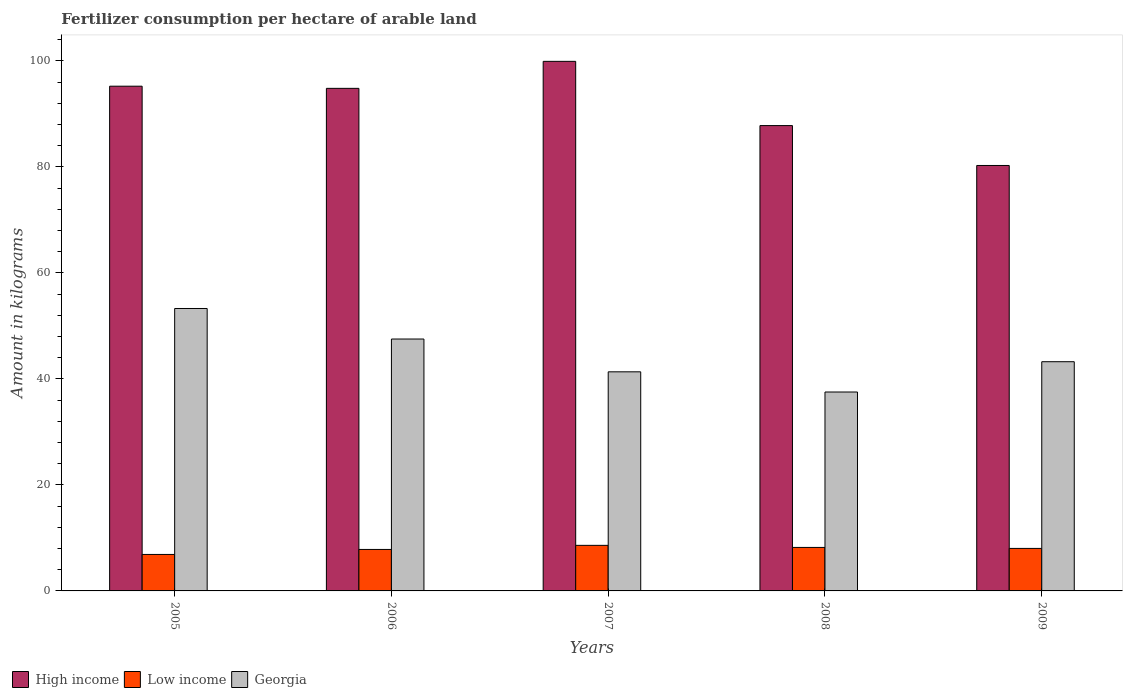How many groups of bars are there?
Your answer should be compact. 5. Are the number of bars per tick equal to the number of legend labels?
Offer a terse response. Yes. Are the number of bars on each tick of the X-axis equal?
Keep it short and to the point. Yes. How many bars are there on the 2nd tick from the left?
Your answer should be very brief. 3. How many bars are there on the 4th tick from the right?
Your response must be concise. 3. In how many cases, is the number of bars for a given year not equal to the number of legend labels?
Your answer should be compact. 0. What is the amount of fertilizer consumption in High income in 2006?
Ensure brevity in your answer.  94.83. Across all years, what is the maximum amount of fertilizer consumption in Low income?
Offer a terse response. 8.6. Across all years, what is the minimum amount of fertilizer consumption in Low income?
Provide a short and direct response. 6.88. What is the total amount of fertilizer consumption in Low income in the graph?
Your response must be concise. 39.53. What is the difference between the amount of fertilizer consumption in High income in 2007 and that in 2008?
Offer a very short reply. 12.12. What is the difference between the amount of fertilizer consumption in High income in 2007 and the amount of fertilizer consumption in Georgia in 2005?
Ensure brevity in your answer.  46.63. What is the average amount of fertilizer consumption in Low income per year?
Make the answer very short. 7.91. In the year 2008, what is the difference between the amount of fertilizer consumption in High income and amount of fertilizer consumption in Low income?
Ensure brevity in your answer.  79.59. What is the ratio of the amount of fertilizer consumption in High income in 2006 to that in 2009?
Ensure brevity in your answer.  1.18. Is the amount of fertilizer consumption in Low income in 2008 less than that in 2009?
Provide a succinct answer. No. Is the difference between the amount of fertilizer consumption in High income in 2008 and 2009 greater than the difference between the amount of fertilizer consumption in Low income in 2008 and 2009?
Keep it short and to the point. Yes. What is the difference between the highest and the second highest amount of fertilizer consumption in High income?
Offer a terse response. 4.69. What is the difference between the highest and the lowest amount of fertilizer consumption in Low income?
Provide a succinct answer. 1.72. In how many years, is the amount of fertilizer consumption in Low income greater than the average amount of fertilizer consumption in Low income taken over all years?
Ensure brevity in your answer.  3. What does the 1st bar from the right in 2008 represents?
Provide a short and direct response. Georgia. Are all the bars in the graph horizontal?
Your response must be concise. No. What is the difference between two consecutive major ticks on the Y-axis?
Provide a short and direct response. 20. Are the values on the major ticks of Y-axis written in scientific E-notation?
Offer a terse response. No. How are the legend labels stacked?
Ensure brevity in your answer.  Horizontal. What is the title of the graph?
Keep it short and to the point. Fertilizer consumption per hectare of arable land. What is the label or title of the Y-axis?
Offer a terse response. Amount in kilograms. What is the Amount in kilograms in High income in 2005?
Your response must be concise. 95.23. What is the Amount in kilograms of Low income in 2005?
Give a very brief answer. 6.88. What is the Amount in kilograms of Georgia in 2005?
Ensure brevity in your answer.  53.29. What is the Amount in kilograms in High income in 2006?
Make the answer very short. 94.83. What is the Amount in kilograms in Low income in 2006?
Your response must be concise. 7.83. What is the Amount in kilograms in Georgia in 2006?
Your response must be concise. 47.53. What is the Amount in kilograms of High income in 2007?
Give a very brief answer. 99.92. What is the Amount in kilograms of Low income in 2007?
Give a very brief answer. 8.6. What is the Amount in kilograms of Georgia in 2007?
Keep it short and to the point. 41.34. What is the Amount in kilograms of High income in 2008?
Your answer should be compact. 87.8. What is the Amount in kilograms in Low income in 2008?
Your answer should be compact. 8.21. What is the Amount in kilograms of Georgia in 2008?
Provide a short and direct response. 37.53. What is the Amount in kilograms of High income in 2009?
Provide a short and direct response. 80.27. What is the Amount in kilograms in Low income in 2009?
Make the answer very short. 8.02. What is the Amount in kilograms in Georgia in 2009?
Make the answer very short. 43.25. Across all years, what is the maximum Amount in kilograms in High income?
Your answer should be compact. 99.92. Across all years, what is the maximum Amount in kilograms in Low income?
Keep it short and to the point. 8.6. Across all years, what is the maximum Amount in kilograms in Georgia?
Your response must be concise. 53.29. Across all years, what is the minimum Amount in kilograms in High income?
Give a very brief answer. 80.27. Across all years, what is the minimum Amount in kilograms in Low income?
Provide a short and direct response. 6.88. Across all years, what is the minimum Amount in kilograms of Georgia?
Your answer should be compact. 37.53. What is the total Amount in kilograms of High income in the graph?
Ensure brevity in your answer.  458.05. What is the total Amount in kilograms of Low income in the graph?
Provide a short and direct response. 39.53. What is the total Amount in kilograms in Georgia in the graph?
Offer a very short reply. 222.93. What is the difference between the Amount in kilograms of High income in 2005 and that in 2006?
Give a very brief answer. 0.41. What is the difference between the Amount in kilograms of Low income in 2005 and that in 2006?
Provide a short and direct response. -0.95. What is the difference between the Amount in kilograms of Georgia in 2005 and that in 2006?
Your answer should be very brief. 5.76. What is the difference between the Amount in kilograms of High income in 2005 and that in 2007?
Give a very brief answer. -4.69. What is the difference between the Amount in kilograms in Low income in 2005 and that in 2007?
Your answer should be very brief. -1.72. What is the difference between the Amount in kilograms of Georgia in 2005 and that in 2007?
Your answer should be compact. 11.95. What is the difference between the Amount in kilograms in High income in 2005 and that in 2008?
Keep it short and to the point. 7.43. What is the difference between the Amount in kilograms in Low income in 2005 and that in 2008?
Your answer should be very brief. -1.33. What is the difference between the Amount in kilograms of Georgia in 2005 and that in 2008?
Offer a very short reply. 15.76. What is the difference between the Amount in kilograms of High income in 2005 and that in 2009?
Your response must be concise. 14.96. What is the difference between the Amount in kilograms in Low income in 2005 and that in 2009?
Offer a very short reply. -1.14. What is the difference between the Amount in kilograms in Georgia in 2005 and that in 2009?
Ensure brevity in your answer.  10.04. What is the difference between the Amount in kilograms of High income in 2006 and that in 2007?
Offer a terse response. -5.09. What is the difference between the Amount in kilograms in Low income in 2006 and that in 2007?
Your answer should be compact. -0.77. What is the difference between the Amount in kilograms of Georgia in 2006 and that in 2007?
Your answer should be compact. 6.19. What is the difference between the Amount in kilograms in High income in 2006 and that in 2008?
Provide a succinct answer. 7.03. What is the difference between the Amount in kilograms of Low income in 2006 and that in 2008?
Your response must be concise. -0.38. What is the difference between the Amount in kilograms of Georgia in 2006 and that in 2008?
Offer a terse response. 10. What is the difference between the Amount in kilograms of High income in 2006 and that in 2009?
Offer a terse response. 14.55. What is the difference between the Amount in kilograms in Low income in 2006 and that in 2009?
Your answer should be very brief. -0.19. What is the difference between the Amount in kilograms of Georgia in 2006 and that in 2009?
Your answer should be very brief. 4.28. What is the difference between the Amount in kilograms of High income in 2007 and that in 2008?
Make the answer very short. 12.12. What is the difference between the Amount in kilograms in Low income in 2007 and that in 2008?
Your response must be concise. 0.39. What is the difference between the Amount in kilograms in Georgia in 2007 and that in 2008?
Offer a terse response. 3.81. What is the difference between the Amount in kilograms of High income in 2007 and that in 2009?
Ensure brevity in your answer.  19.65. What is the difference between the Amount in kilograms in Low income in 2007 and that in 2009?
Your answer should be very brief. 0.58. What is the difference between the Amount in kilograms in Georgia in 2007 and that in 2009?
Your answer should be compact. -1.91. What is the difference between the Amount in kilograms in High income in 2008 and that in 2009?
Your response must be concise. 7.53. What is the difference between the Amount in kilograms of Low income in 2008 and that in 2009?
Your answer should be compact. 0.19. What is the difference between the Amount in kilograms in Georgia in 2008 and that in 2009?
Ensure brevity in your answer.  -5.72. What is the difference between the Amount in kilograms in High income in 2005 and the Amount in kilograms in Low income in 2006?
Your answer should be very brief. 87.4. What is the difference between the Amount in kilograms of High income in 2005 and the Amount in kilograms of Georgia in 2006?
Offer a terse response. 47.7. What is the difference between the Amount in kilograms of Low income in 2005 and the Amount in kilograms of Georgia in 2006?
Provide a short and direct response. -40.65. What is the difference between the Amount in kilograms of High income in 2005 and the Amount in kilograms of Low income in 2007?
Provide a succinct answer. 86.63. What is the difference between the Amount in kilograms of High income in 2005 and the Amount in kilograms of Georgia in 2007?
Offer a terse response. 53.89. What is the difference between the Amount in kilograms in Low income in 2005 and the Amount in kilograms in Georgia in 2007?
Offer a terse response. -34.46. What is the difference between the Amount in kilograms in High income in 2005 and the Amount in kilograms in Low income in 2008?
Your answer should be compact. 87.02. What is the difference between the Amount in kilograms of High income in 2005 and the Amount in kilograms of Georgia in 2008?
Ensure brevity in your answer.  57.7. What is the difference between the Amount in kilograms of Low income in 2005 and the Amount in kilograms of Georgia in 2008?
Offer a very short reply. -30.65. What is the difference between the Amount in kilograms in High income in 2005 and the Amount in kilograms in Low income in 2009?
Your answer should be very brief. 87.21. What is the difference between the Amount in kilograms of High income in 2005 and the Amount in kilograms of Georgia in 2009?
Ensure brevity in your answer.  51.98. What is the difference between the Amount in kilograms of Low income in 2005 and the Amount in kilograms of Georgia in 2009?
Ensure brevity in your answer.  -36.37. What is the difference between the Amount in kilograms in High income in 2006 and the Amount in kilograms in Low income in 2007?
Give a very brief answer. 86.23. What is the difference between the Amount in kilograms of High income in 2006 and the Amount in kilograms of Georgia in 2007?
Give a very brief answer. 53.49. What is the difference between the Amount in kilograms of Low income in 2006 and the Amount in kilograms of Georgia in 2007?
Keep it short and to the point. -33.51. What is the difference between the Amount in kilograms of High income in 2006 and the Amount in kilograms of Low income in 2008?
Give a very brief answer. 86.62. What is the difference between the Amount in kilograms of High income in 2006 and the Amount in kilograms of Georgia in 2008?
Provide a succinct answer. 57.29. What is the difference between the Amount in kilograms in Low income in 2006 and the Amount in kilograms in Georgia in 2008?
Give a very brief answer. -29.7. What is the difference between the Amount in kilograms in High income in 2006 and the Amount in kilograms in Low income in 2009?
Offer a very short reply. 86.81. What is the difference between the Amount in kilograms in High income in 2006 and the Amount in kilograms in Georgia in 2009?
Provide a succinct answer. 51.58. What is the difference between the Amount in kilograms in Low income in 2006 and the Amount in kilograms in Georgia in 2009?
Keep it short and to the point. -35.42. What is the difference between the Amount in kilograms in High income in 2007 and the Amount in kilograms in Low income in 2008?
Provide a succinct answer. 91.71. What is the difference between the Amount in kilograms in High income in 2007 and the Amount in kilograms in Georgia in 2008?
Provide a short and direct response. 62.39. What is the difference between the Amount in kilograms in Low income in 2007 and the Amount in kilograms in Georgia in 2008?
Provide a succinct answer. -28.93. What is the difference between the Amount in kilograms of High income in 2007 and the Amount in kilograms of Low income in 2009?
Offer a very short reply. 91.9. What is the difference between the Amount in kilograms of High income in 2007 and the Amount in kilograms of Georgia in 2009?
Your response must be concise. 56.67. What is the difference between the Amount in kilograms in Low income in 2007 and the Amount in kilograms in Georgia in 2009?
Ensure brevity in your answer.  -34.65. What is the difference between the Amount in kilograms of High income in 2008 and the Amount in kilograms of Low income in 2009?
Your answer should be very brief. 79.78. What is the difference between the Amount in kilograms in High income in 2008 and the Amount in kilograms in Georgia in 2009?
Provide a short and direct response. 44.55. What is the difference between the Amount in kilograms in Low income in 2008 and the Amount in kilograms in Georgia in 2009?
Ensure brevity in your answer.  -35.04. What is the average Amount in kilograms in High income per year?
Offer a terse response. 91.61. What is the average Amount in kilograms of Low income per year?
Offer a terse response. 7.91. What is the average Amount in kilograms in Georgia per year?
Your response must be concise. 44.59. In the year 2005, what is the difference between the Amount in kilograms in High income and Amount in kilograms in Low income?
Make the answer very short. 88.35. In the year 2005, what is the difference between the Amount in kilograms of High income and Amount in kilograms of Georgia?
Your answer should be very brief. 41.94. In the year 2005, what is the difference between the Amount in kilograms of Low income and Amount in kilograms of Georgia?
Your response must be concise. -46.41. In the year 2006, what is the difference between the Amount in kilograms of High income and Amount in kilograms of Low income?
Offer a terse response. 87. In the year 2006, what is the difference between the Amount in kilograms of High income and Amount in kilograms of Georgia?
Provide a short and direct response. 47.3. In the year 2006, what is the difference between the Amount in kilograms in Low income and Amount in kilograms in Georgia?
Provide a short and direct response. -39.7. In the year 2007, what is the difference between the Amount in kilograms of High income and Amount in kilograms of Low income?
Provide a succinct answer. 91.32. In the year 2007, what is the difference between the Amount in kilograms of High income and Amount in kilograms of Georgia?
Keep it short and to the point. 58.58. In the year 2007, what is the difference between the Amount in kilograms in Low income and Amount in kilograms in Georgia?
Keep it short and to the point. -32.74. In the year 2008, what is the difference between the Amount in kilograms in High income and Amount in kilograms in Low income?
Make the answer very short. 79.59. In the year 2008, what is the difference between the Amount in kilograms of High income and Amount in kilograms of Georgia?
Offer a very short reply. 50.27. In the year 2008, what is the difference between the Amount in kilograms in Low income and Amount in kilograms in Georgia?
Make the answer very short. -29.32. In the year 2009, what is the difference between the Amount in kilograms of High income and Amount in kilograms of Low income?
Your response must be concise. 72.25. In the year 2009, what is the difference between the Amount in kilograms of High income and Amount in kilograms of Georgia?
Your response must be concise. 37.03. In the year 2009, what is the difference between the Amount in kilograms in Low income and Amount in kilograms in Georgia?
Keep it short and to the point. -35.23. What is the ratio of the Amount in kilograms of High income in 2005 to that in 2006?
Your answer should be very brief. 1. What is the ratio of the Amount in kilograms of Low income in 2005 to that in 2006?
Your answer should be very brief. 0.88. What is the ratio of the Amount in kilograms of Georgia in 2005 to that in 2006?
Your response must be concise. 1.12. What is the ratio of the Amount in kilograms of High income in 2005 to that in 2007?
Offer a very short reply. 0.95. What is the ratio of the Amount in kilograms in Low income in 2005 to that in 2007?
Your answer should be compact. 0.8. What is the ratio of the Amount in kilograms in Georgia in 2005 to that in 2007?
Provide a succinct answer. 1.29. What is the ratio of the Amount in kilograms in High income in 2005 to that in 2008?
Offer a terse response. 1.08. What is the ratio of the Amount in kilograms of Low income in 2005 to that in 2008?
Provide a short and direct response. 0.84. What is the ratio of the Amount in kilograms of Georgia in 2005 to that in 2008?
Make the answer very short. 1.42. What is the ratio of the Amount in kilograms of High income in 2005 to that in 2009?
Provide a succinct answer. 1.19. What is the ratio of the Amount in kilograms in Low income in 2005 to that in 2009?
Your answer should be compact. 0.86. What is the ratio of the Amount in kilograms in Georgia in 2005 to that in 2009?
Keep it short and to the point. 1.23. What is the ratio of the Amount in kilograms in High income in 2006 to that in 2007?
Make the answer very short. 0.95. What is the ratio of the Amount in kilograms in Low income in 2006 to that in 2007?
Keep it short and to the point. 0.91. What is the ratio of the Amount in kilograms of Georgia in 2006 to that in 2007?
Offer a terse response. 1.15. What is the ratio of the Amount in kilograms of High income in 2006 to that in 2008?
Provide a short and direct response. 1.08. What is the ratio of the Amount in kilograms of Low income in 2006 to that in 2008?
Make the answer very short. 0.95. What is the ratio of the Amount in kilograms in Georgia in 2006 to that in 2008?
Offer a terse response. 1.27. What is the ratio of the Amount in kilograms of High income in 2006 to that in 2009?
Provide a short and direct response. 1.18. What is the ratio of the Amount in kilograms of Low income in 2006 to that in 2009?
Offer a very short reply. 0.98. What is the ratio of the Amount in kilograms of Georgia in 2006 to that in 2009?
Offer a very short reply. 1.1. What is the ratio of the Amount in kilograms of High income in 2007 to that in 2008?
Provide a succinct answer. 1.14. What is the ratio of the Amount in kilograms of Low income in 2007 to that in 2008?
Provide a short and direct response. 1.05. What is the ratio of the Amount in kilograms of Georgia in 2007 to that in 2008?
Your response must be concise. 1.1. What is the ratio of the Amount in kilograms of High income in 2007 to that in 2009?
Give a very brief answer. 1.24. What is the ratio of the Amount in kilograms of Low income in 2007 to that in 2009?
Ensure brevity in your answer.  1.07. What is the ratio of the Amount in kilograms in Georgia in 2007 to that in 2009?
Make the answer very short. 0.96. What is the ratio of the Amount in kilograms in High income in 2008 to that in 2009?
Your response must be concise. 1.09. What is the ratio of the Amount in kilograms of Low income in 2008 to that in 2009?
Your answer should be very brief. 1.02. What is the ratio of the Amount in kilograms in Georgia in 2008 to that in 2009?
Make the answer very short. 0.87. What is the difference between the highest and the second highest Amount in kilograms of High income?
Your answer should be compact. 4.69. What is the difference between the highest and the second highest Amount in kilograms in Low income?
Offer a terse response. 0.39. What is the difference between the highest and the second highest Amount in kilograms in Georgia?
Make the answer very short. 5.76. What is the difference between the highest and the lowest Amount in kilograms in High income?
Your answer should be compact. 19.65. What is the difference between the highest and the lowest Amount in kilograms in Low income?
Your response must be concise. 1.72. What is the difference between the highest and the lowest Amount in kilograms of Georgia?
Provide a short and direct response. 15.76. 